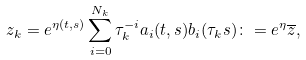<formula> <loc_0><loc_0><loc_500><loc_500>z _ { k } = e ^ { \eta ( t , s ) } \sum _ { i = 0 } ^ { N _ { k } } \tau _ { k } ^ { - i } a _ { i } ( t , s ) b _ { i } ( \tau _ { k } s ) \colon = e ^ { \eta } \overline { z } ,</formula> 